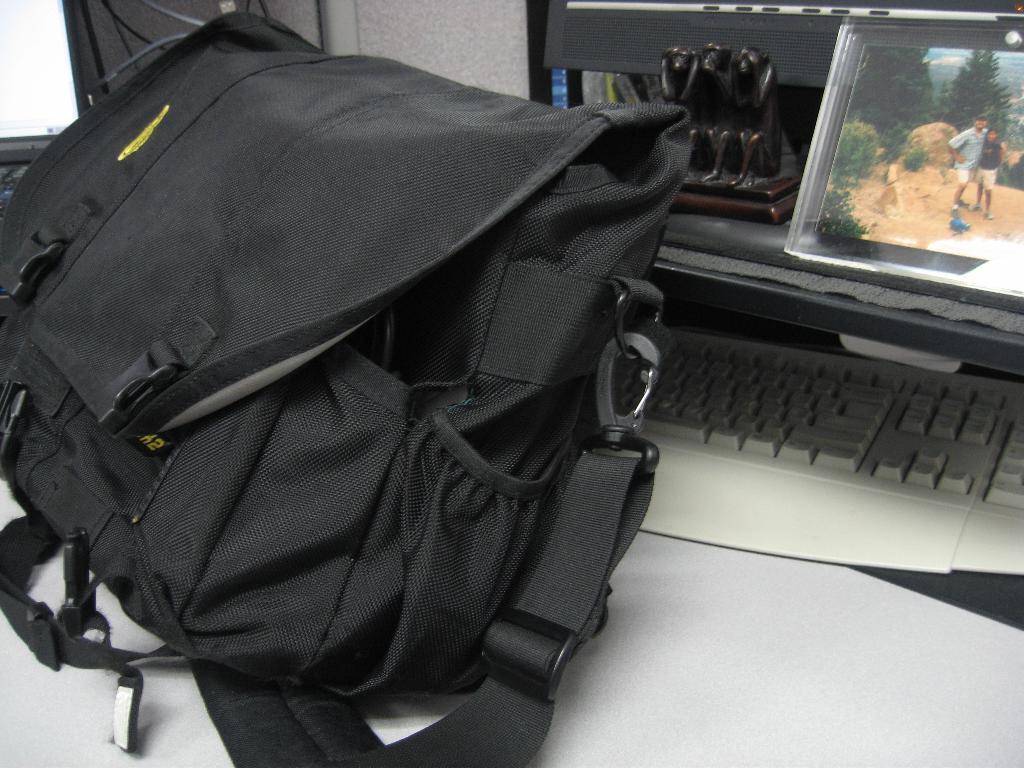Please provide a concise description of this image. We can see black color bag,screen,keyboard,sculpture,monitor on the table. 